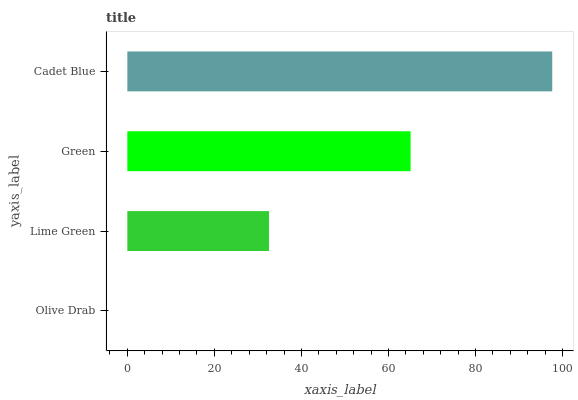Is Olive Drab the minimum?
Answer yes or no. Yes. Is Cadet Blue the maximum?
Answer yes or no. Yes. Is Lime Green the minimum?
Answer yes or no. No. Is Lime Green the maximum?
Answer yes or no. No. Is Lime Green greater than Olive Drab?
Answer yes or no. Yes. Is Olive Drab less than Lime Green?
Answer yes or no. Yes. Is Olive Drab greater than Lime Green?
Answer yes or no. No. Is Lime Green less than Olive Drab?
Answer yes or no. No. Is Green the high median?
Answer yes or no. Yes. Is Lime Green the low median?
Answer yes or no. Yes. Is Cadet Blue the high median?
Answer yes or no. No. Is Cadet Blue the low median?
Answer yes or no. No. 